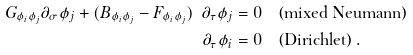Convert formula to latex. <formula><loc_0><loc_0><loc_500><loc_500>G _ { \phi _ { i } \phi _ { j } } \partial _ { \sigma } \phi _ { j } + ( B _ { \phi _ { i } \phi _ { j } } - F _ { \phi _ { i } \phi _ { j } } ) \ \partial _ { \tau } \phi _ { j } & = 0 \quad \text {(mixed Neumann)} \\ \partial _ { \tau } \phi _ { i } & = 0 \quad \text {(Dirichlet)} \, .</formula> 